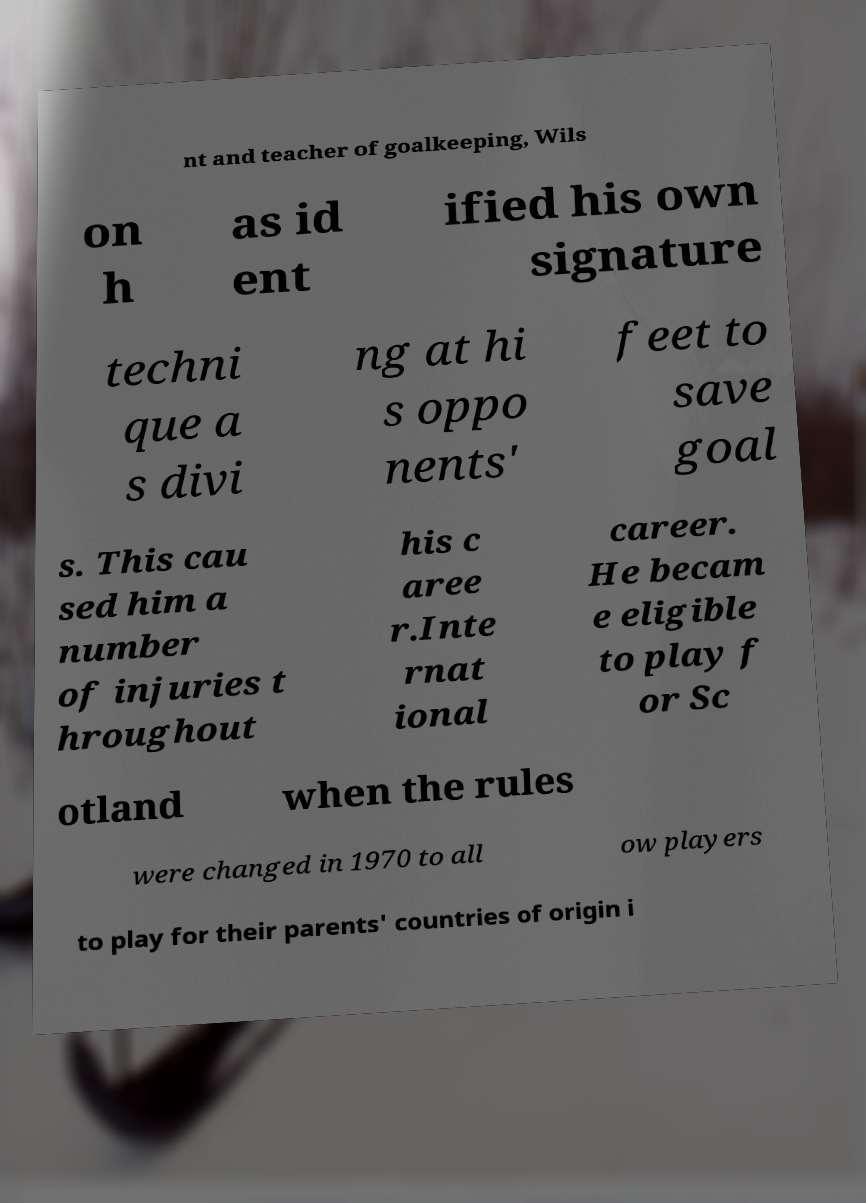Can you accurately transcribe the text from the provided image for me? nt and teacher of goalkeeping, Wils on h as id ent ified his own signature techni que a s divi ng at hi s oppo nents' feet to save goal s. This cau sed him a number of injuries t hroughout his c aree r.Inte rnat ional career. He becam e eligible to play f or Sc otland when the rules were changed in 1970 to all ow players to play for their parents' countries of origin i 